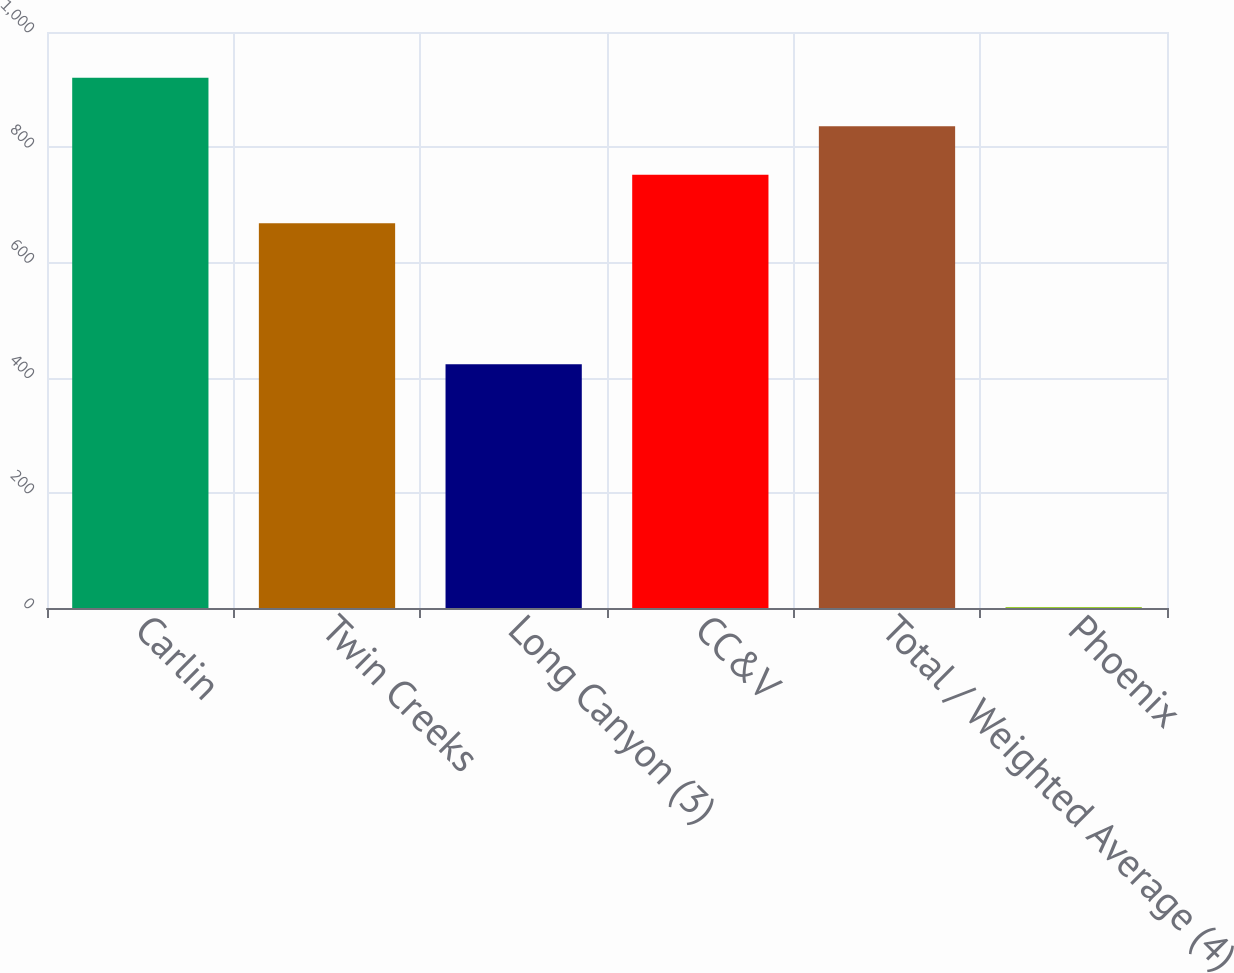Convert chart to OTSL. <chart><loc_0><loc_0><loc_500><loc_500><bar_chart><fcel>Carlin<fcel>Twin Creeks<fcel>Long Canyon (3)<fcel>CC&V<fcel>Total / Weighted Average (4)<fcel>Phoenix<nl><fcel>920.36<fcel>668<fcel>423<fcel>752.12<fcel>836.24<fcel>1.83<nl></chart> 